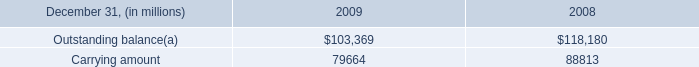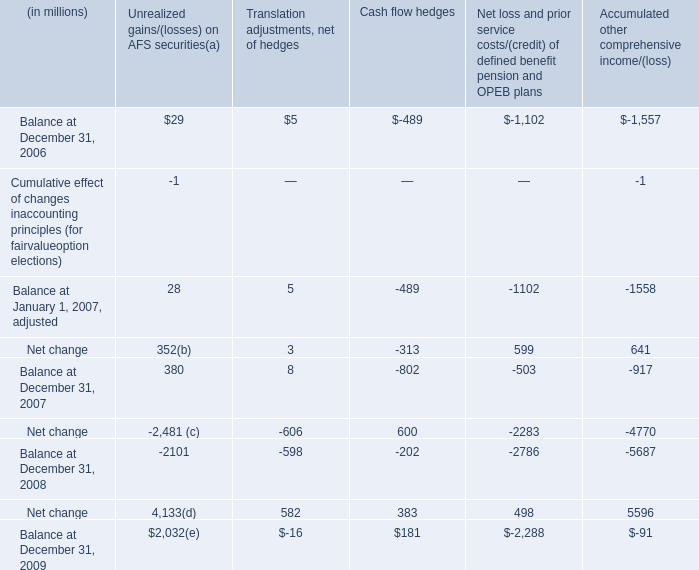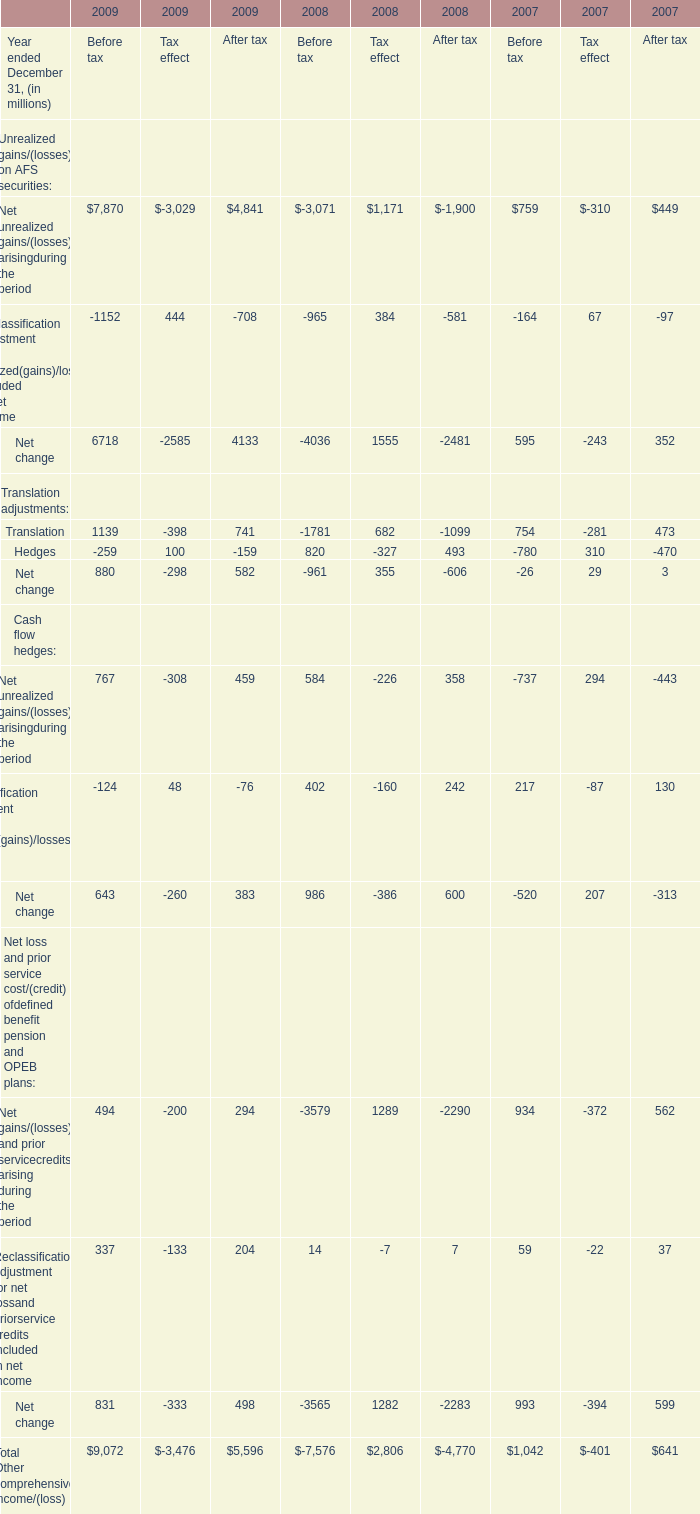in 2009 , what percentage of its net aggregate carrying amount did the firm record as its allowance for loan losses? 
Computations: (1.6 / 47.2)
Answer: 0.0339. 